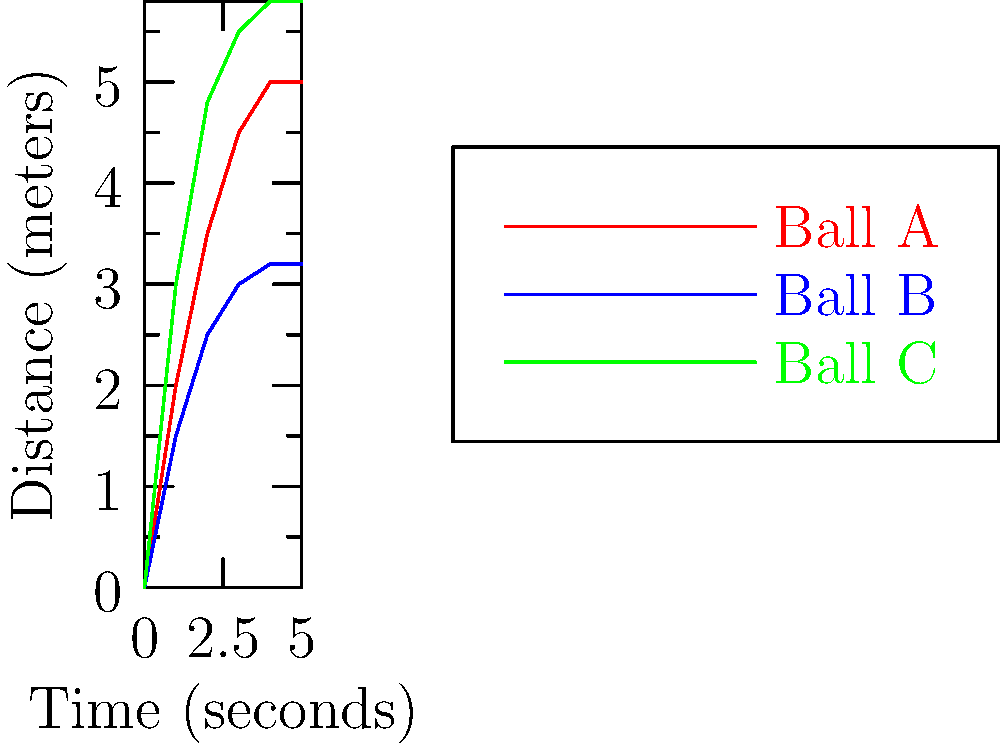In a women's bowling tournament inspired by the Olympic spirit, three professional bowlers are analyzing their ball trajectories. The graph shows the distance traveled by three bowling balls (A, B, and C) over time. Which ball reaches its maximum distance first, and what does this imply about the throw? To answer this question, we need to analyze the trajectories of the three bowling balls:

1. Examine each line on the graph:
   - Red line (Ball A): Gradually increases and plateaus around 5 meters
   - Blue line (Ball B): Increases slower and plateaus around 3.2 meters
   - Green line (Ball C): Increases rapidly and plateaus around 5.8 meters

2. Identify when each ball reaches its maximum distance:
   - Ball A: Reaches maximum at about 5 seconds
   - Ball B: Reaches maximum at about 4 seconds
   - Ball C: Reaches maximum at about 4 seconds

3. Compare the times:
   Ball B and C both reach their maximum distance first, at approximately 4 seconds.

4. Interpret the results:
   Ball C reaches the highest point (5.8 meters) in the same time as Ball B reaches its lower maximum (3.2 meters). This implies that Ball C was thrown with greater force and a more optimal angle.

5. Relate to bowling technique:
   The thrower of Ball C likely combined power with proper technique, demonstrating how skill and strength can maximize performance in women's bowling.
Answer: Ball C; thrown with greater force and optimal angle. 